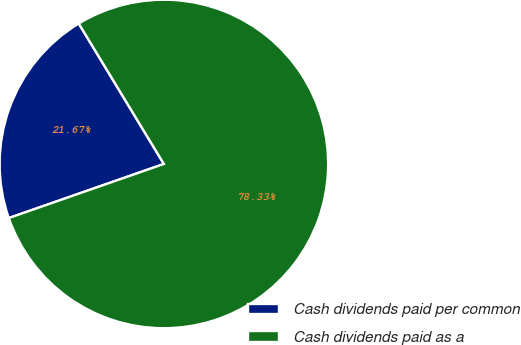Convert chart to OTSL. <chart><loc_0><loc_0><loc_500><loc_500><pie_chart><fcel>Cash dividends paid per common<fcel>Cash dividends paid as a<nl><fcel>21.67%<fcel>78.33%<nl></chart> 